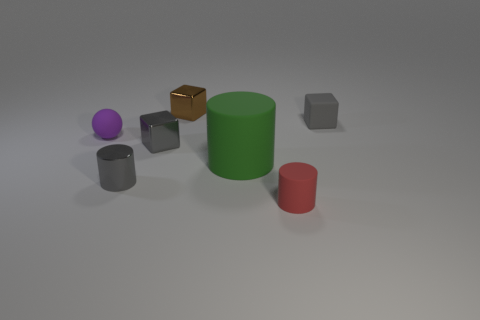Add 1 brown metallic spheres. How many objects exist? 8 Subtract all cubes. How many objects are left? 4 Subtract all small rubber cylinders. Subtract all red rubber cylinders. How many objects are left? 5 Add 2 big cylinders. How many big cylinders are left? 3 Add 1 green rubber things. How many green rubber things exist? 2 Subtract 1 green cylinders. How many objects are left? 6 